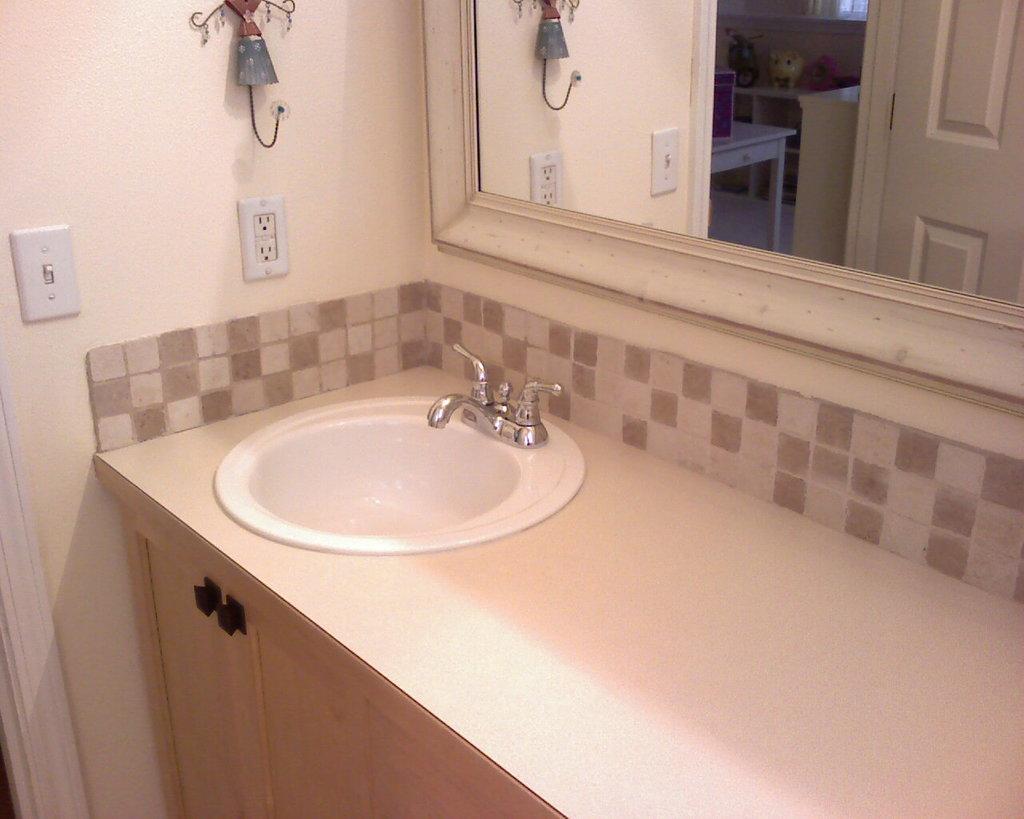How would you summarize this image in a sentence or two? In the image there is a sink and in front of the sink there is a mirror, under the sink there are cupboards, in the background there is a wall and there is a switch board attached to the wall. 